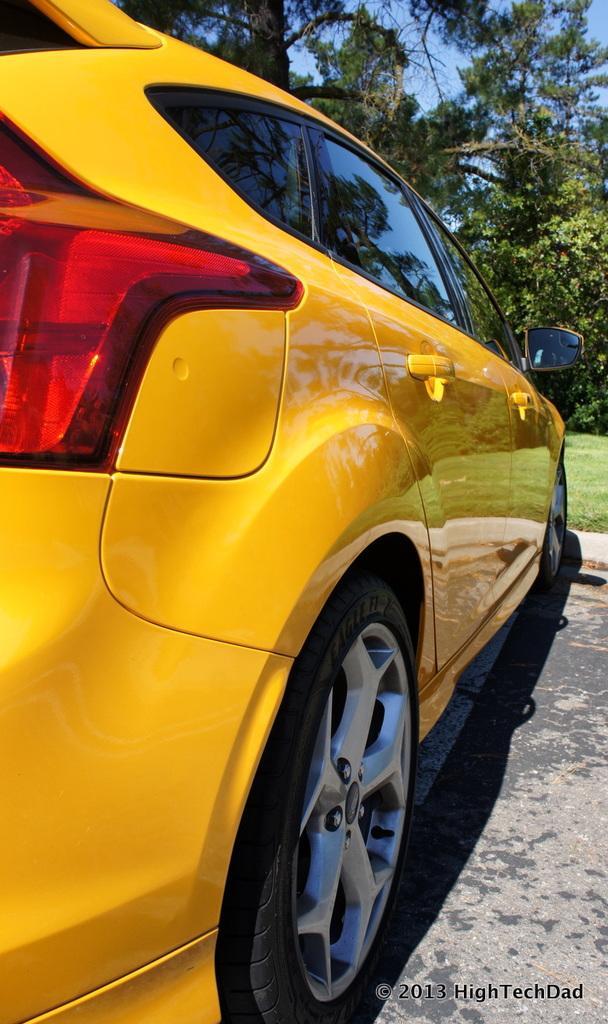Describe this image in one or two sentences. In this picture we can see a car on the road and in the background we can see trees, sky, in the bottom right we can see some text. 